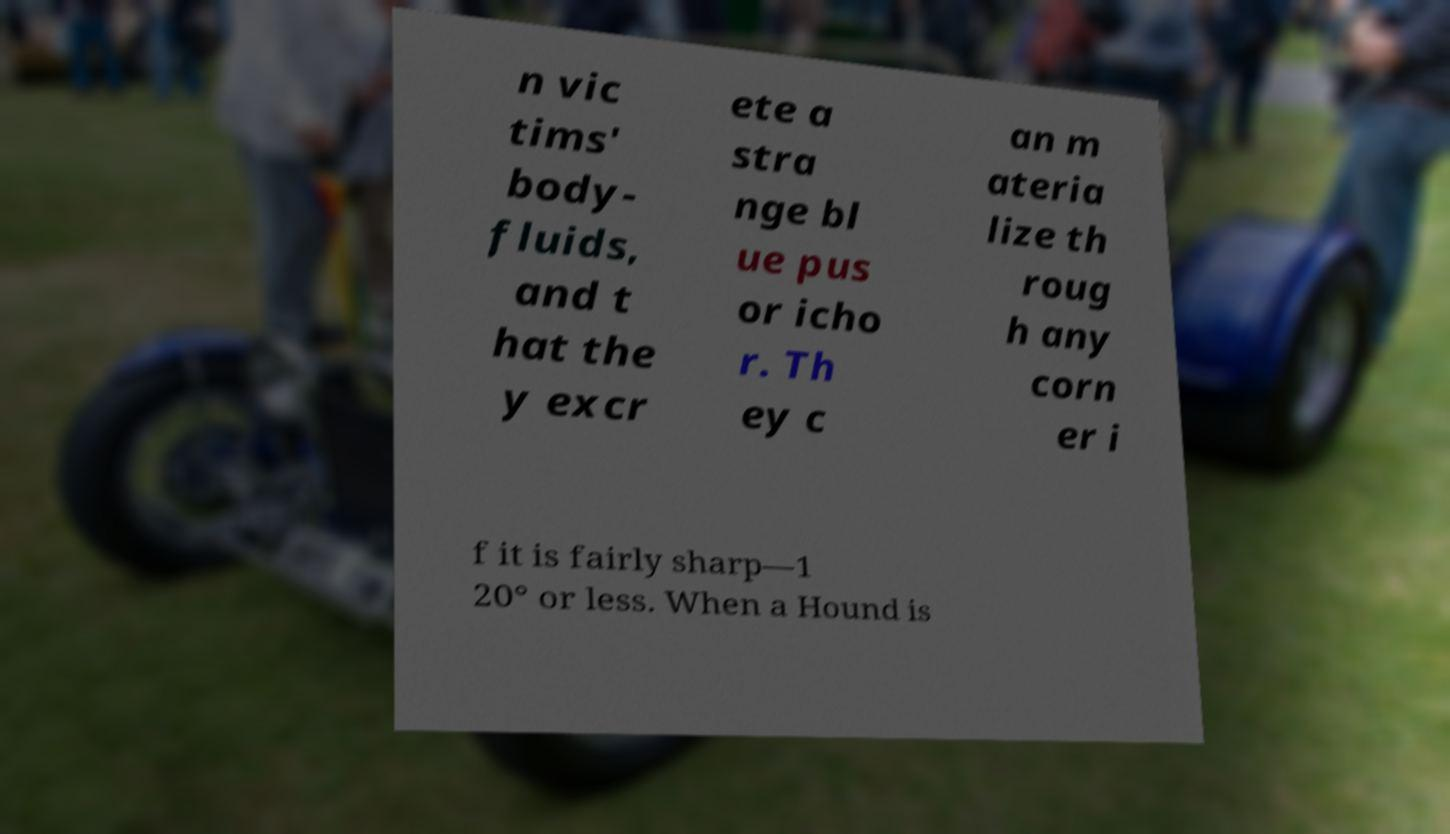There's text embedded in this image that I need extracted. Can you transcribe it verbatim? n vic tims' body- fluids, and t hat the y excr ete a stra nge bl ue pus or icho r. Th ey c an m ateria lize th roug h any corn er i f it is fairly sharp—1 20° or less. When a Hound is 